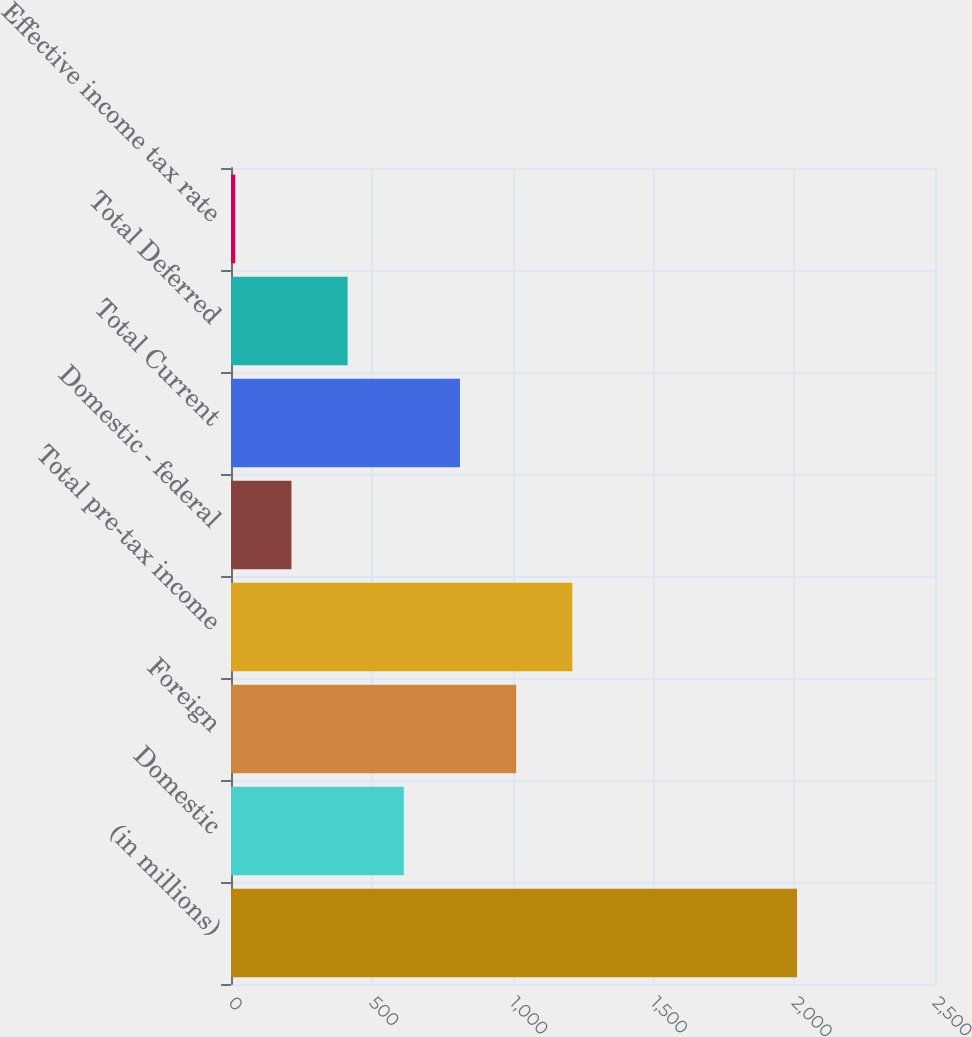Convert chart. <chart><loc_0><loc_0><loc_500><loc_500><bar_chart><fcel>(in millions)<fcel>Domestic<fcel>Foreign<fcel>Total pre-tax income<fcel>Domestic - federal<fcel>Total Current<fcel>Total Deferred<fcel>Effective income tax rate<nl><fcel>2010<fcel>613.64<fcel>1012.6<fcel>1212.08<fcel>214.68<fcel>813.12<fcel>414.16<fcel>15.2<nl></chart> 